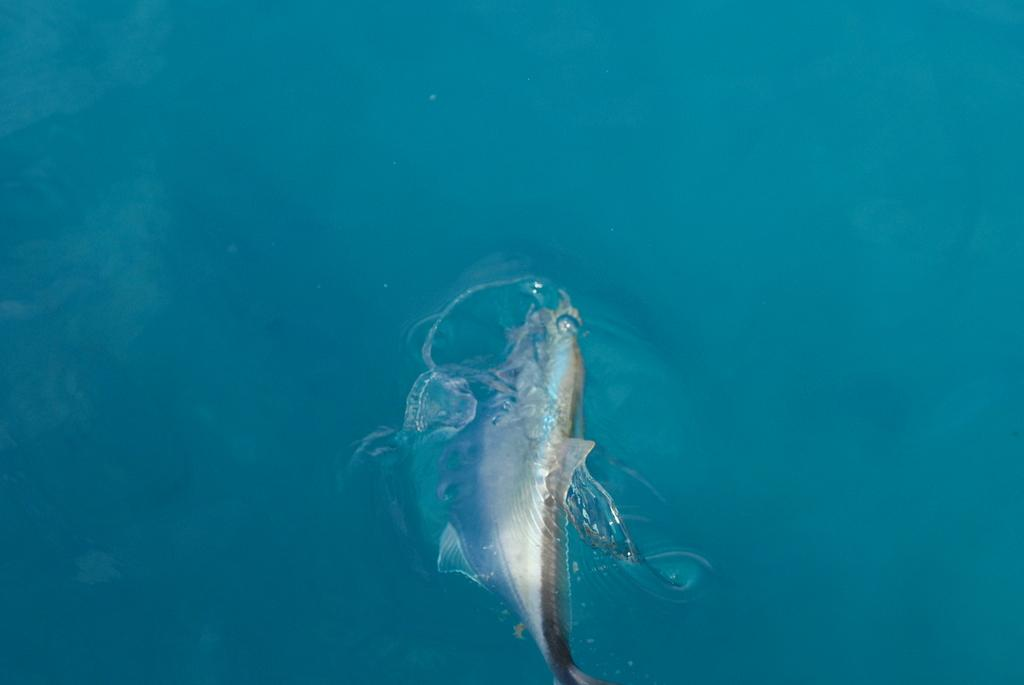What type of animal can be seen in the image? There is a fish in the water in the image. Where is the fish located in the image? The fish is in the water in the image. What type of window can be seen in the image? There is no window present in the image; it features a fish in the water. What adjustment can be made to the base of the fish in the image? There is no base or adjustment feature present in the image, as it only shows a fish in the water. 